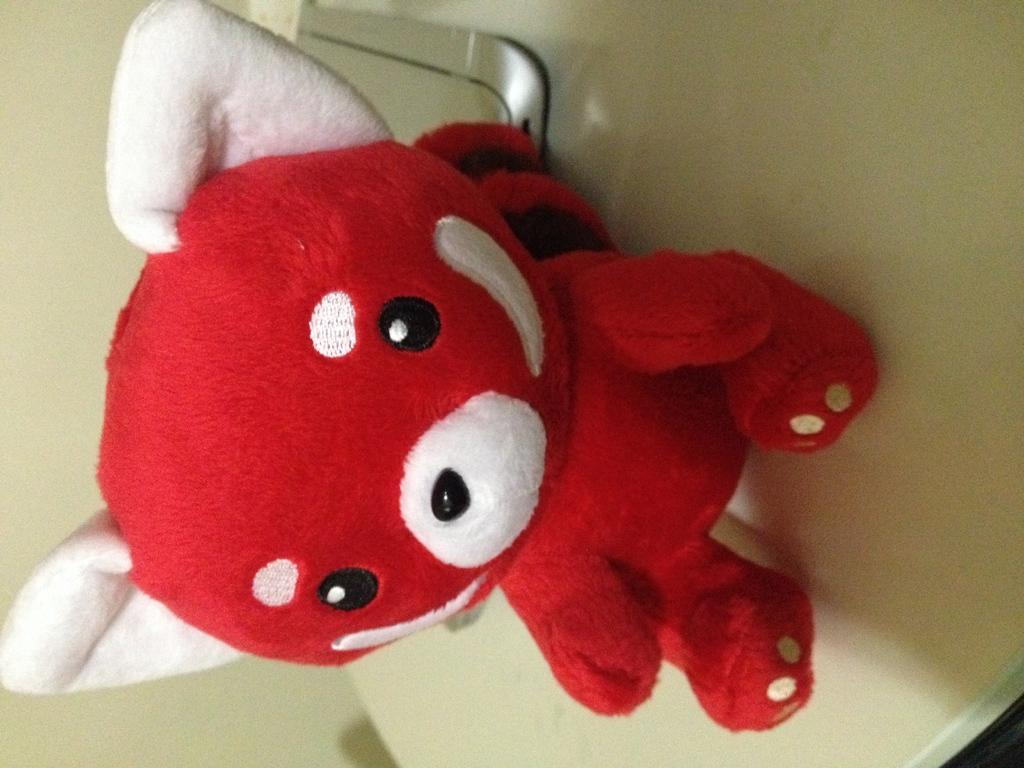What color is the doll in the image? The doll in the image is red-colored. Where is the doll located in the image? The doll is on a table in the image. What sense does the doll use to detect the presence of a wound in the image? The doll does not have any senses, as it is an inanimate object, and therefore cannot detect the presence of a wound. 